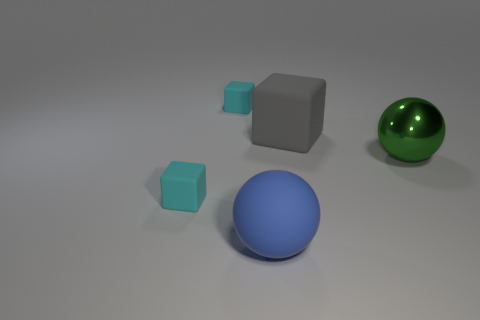Add 2 cyan matte blocks. How many objects exist? 7 Subtract all cubes. How many objects are left? 2 Subtract all cyan matte things. Subtract all tiny cyan blocks. How many objects are left? 1 Add 5 rubber cubes. How many rubber cubes are left? 8 Add 1 green things. How many green things exist? 2 Subtract 1 blue spheres. How many objects are left? 4 